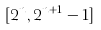Convert formula to latex. <formula><loc_0><loc_0><loc_500><loc_500>[ 2 ^ { n } , 2 ^ { n + 1 } - 1 ]</formula> 